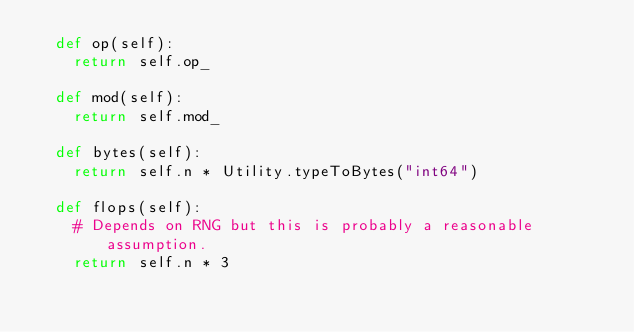Convert code to text. <code><loc_0><loc_0><loc_500><loc_500><_Python_>	def op(self):
		return self.op_

	def mod(self):
		return self.mod_

	def bytes(self):
		return self.n * Utility.typeToBytes("int64")

	def flops(self):
		# Depends on RNG but this is probably a reasonable assumption.
		return self.n * 3
</code> 